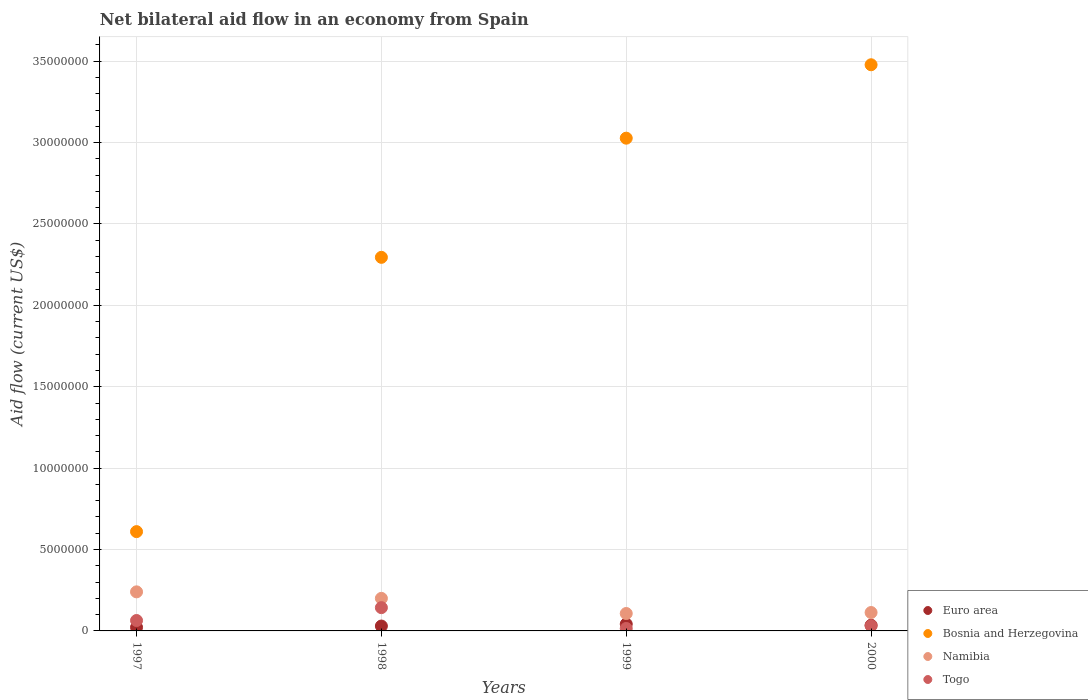How many different coloured dotlines are there?
Offer a very short reply. 4. What is the net bilateral aid flow in Euro area in 1998?
Offer a very short reply. 3.00e+05. Across all years, what is the maximum net bilateral aid flow in Namibia?
Provide a short and direct response. 2.40e+06. Across all years, what is the minimum net bilateral aid flow in Namibia?
Offer a very short reply. 1.07e+06. In which year was the net bilateral aid flow in Euro area minimum?
Your answer should be very brief. 1997. What is the total net bilateral aid flow in Namibia in the graph?
Your response must be concise. 6.60e+06. What is the difference between the net bilateral aid flow in Euro area in 1998 and the net bilateral aid flow in Namibia in 1997?
Your answer should be compact. -2.10e+06. What is the average net bilateral aid flow in Bosnia and Herzegovina per year?
Give a very brief answer. 2.35e+07. In the year 1998, what is the difference between the net bilateral aid flow in Euro area and net bilateral aid flow in Namibia?
Ensure brevity in your answer.  -1.70e+06. In how many years, is the net bilateral aid flow in Togo greater than 34000000 US$?
Provide a short and direct response. 0. What is the ratio of the net bilateral aid flow in Namibia in 1998 to that in 1999?
Offer a very short reply. 1.87. Is the net bilateral aid flow in Namibia in 1998 less than that in 1999?
Make the answer very short. No. What is the difference between the highest and the lowest net bilateral aid flow in Togo?
Make the answer very short. 1.28e+06. In how many years, is the net bilateral aid flow in Euro area greater than the average net bilateral aid flow in Euro area taken over all years?
Provide a short and direct response. 2. Is the sum of the net bilateral aid flow in Euro area in 1998 and 2000 greater than the maximum net bilateral aid flow in Togo across all years?
Offer a very short reply. No. Is it the case that in every year, the sum of the net bilateral aid flow in Bosnia and Herzegovina and net bilateral aid flow in Euro area  is greater than the sum of net bilateral aid flow in Namibia and net bilateral aid flow in Togo?
Your answer should be compact. Yes. Is it the case that in every year, the sum of the net bilateral aid flow in Togo and net bilateral aid flow in Euro area  is greater than the net bilateral aid flow in Bosnia and Herzegovina?
Offer a very short reply. No. Is the net bilateral aid flow in Euro area strictly less than the net bilateral aid flow in Bosnia and Herzegovina over the years?
Keep it short and to the point. Yes. How many dotlines are there?
Your answer should be very brief. 4. How many years are there in the graph?
Provide a succinct answer. 4. Where does the legend appear in the graph?
Your answer should be compact. Bottom right. How are the legend labels stacked?
Offer a terse response. Vertical. What is the title of the graph?
Offer a terse response. Net bilateral aid flow in an economy from Spain. Does "Cyprus" appear as one of the legend labels in the graph?
Offer a terse response. No. What is the label or title of the X-axis?
Keep it short and to the point. Years. What is the Aid flow (current US$) of Euro area in 1997?
Ensure brevity in your answer.  2.20e+05. What is the Aid flow (current US$) in Bosnia and Herzegovina in 1997?
Your answer should be very brief. 6.10e+06. What is the Aid flow (current US$) in Namibia in 1997?
Your response must be concise. 2.40e+06. What is the Aid flow (current US$) in Togo in 1997?
Make the answer very short. 6.40e+05. What is the Aid flow (current US$) of Bosnia and Herzegovina in 1998?
Give a very brief answer. 2.30e+07. What is the Aid flow (current US$) in Togo in 1998?
Make the answer very short. 1.43e+06. What is the Aid flow (current US$) of Euro area in 1999?
Offer a very short reply. 4.20e+05. What is the Aid flow (current US$) in Bosnia and Herzegovina in 1999?
Provide a succinct answer. 3.03e+07. What is the Aid flow (current US$) in Namibia in 1999?
Your response must be concise. 1.07e+06. What is the Aid flow (current US$) in Bosnia and Herzegovina in 2000?
Make the answer very short. 3.48e+07. What is the Aid flow (current US$) in Namibia in 2000?
Offer a very short reply. 1.13e+06. Across all years, what is the maximum Aid flow (current US$) in Bosnia and Herzegovina?
Offer a terse response. 3.48e+07. Across all years, what is the maximum Aid flow (current US$) in Namibia?
Your answer should be compact. 2.40e+06. Across all years, what is the maximum Aid flow (current US$) in Togo?
Offer a terse response. 1.43e+06. Across all years, what is the minimum Aid flow (current US$) of Euro area?
Offer a very short reply. 2.20e+05. Across all years, what is the minimum Aid flow (current US$) in Bosnia and Herzegovina?
Your answer should be compact. 6.10e+06. Across all years, what is the minimum Aid flow (current US$) in Namibia?
Ensure brevity in your answer.  1.07e+06. Across all years, what is the minimum Aid flow (current US$) of Togo?
Make the answer very short. 1.50e+05. What is the total Aid flow (current US$) of Euro area in the graph?
Give a very brief answer. 1.29e+06. What is the total Aid flow (current US$) of Bosnia and Herzegovina in the graph?
Ensure brevity in your answer.  9.41e+07. What is the total Aid flow (current US$) in Namibia in the graph?
Ensure brevity in your answer.  6.60e+06. What is the total Aid flow (current US$) in Togo in the graph?
Your response must be concise. 2.54e+06. What is the difference between the Aid flow (current US$) of Bosnia and Herzegovina in 1997 and that in 1998?
Your answer should be compact. -1.68e+07. What is the difference between the Aid flow (current US$) of Togo in 1997 and that in 1998?
Offer a terse response. -7.90e+05. What is the difference between the Aid flow (current US$) of Euro area in 1997 and that in 1999?
Your answer should be very brief. -2.00e+05. What is the difference between the Aid flow (current US$) of Bosnia and Herzegovina in 1997 and that in 1999?
Keep it short and to the point. -2.42e+07. What is the difference between the Aid flow (current US$) in Namibia in 1997 and that in 1999?
Offer a terse response. 1.33e+06. What is the difference between the Aid flow (current US$) in Togo in 1997 and that in 1999?
Keep it short and to the point. 4.90e+05. What is the difference between the Aid flow (current US$) in Bosnia and Herzegovina in 1997 and that in 2000?
Offer a terse response. -2.87e+07. What is the difference between the Aid flow (current US$) of Namibia in 1997 and that in 2000?
Offer a very short reply. 1.27e+06. What is the difference between the Aid flow (current US$) of Bosnia and Herzegovina in 1998 and that in 1999?
Your answer should be compact. -7.32e+06. What is the difference between the Aid flow (current US$) in Namibia in 1998 and that in 1999?
Your answer should be compact. 9.30e+05. What is the difference between the Aid flow (current US$) in Togo in 1998 and that in 1999?
Offer a terse response. 1.28e+06. What is the difference between the Aid flow (current US$) in Bosnia and Herzegovina in 1998 and that in 2000?
Offer a very short reply. -1.18e+07. What is the difference between the Aid flow (current US$) in Namibia in 1998 and that in 2000?
Offer a very short reply. 8.70e+05. What is the difference between the Aid flow (current US$) in Togo in 1998 and that in 2000?
Ensure brevity in your answer.  1.11e+06. What is the difference between the Aid flow (current US$) of Bosnia and Herzegovina in 1999 and that in 2000?
Give a very brief answer. -4.51e+06. What is the difference between the Aid flow (current US$) in Namibia in 1999 and that in 2000?
Provide a succinct answer. -6.00e+04. What is the difference between the Aid flow (current US$) in Euro area in 1997 and the Aid flow (current US$) in Bosnia and Herzegovina in 1998?
Make the answer very short. -2.27e+07. What is the difference between the Aid flow (current US$) in Euro area in 1997 and the Aid flow (current US$) in Namibia in 1998?
Give a very brief answer. -1.78e+06. What is the difference between the Aid flow (current US$) in Euro area in 1997 and the Aid flow (current US$) in Togo in 1998?
Your response must be concise. -1.21e+06. What is the difference between the Aid flow (current US$) of Bosnia and Herzegovina in 1997 and the Aid flow (current US$) of Namibia in 1998?
Offer a terse response. 4.10e+06. What is the difference between the Aid flow (current US$) in Bosnia and Herzegovina in 1997 and the Aid flow (current US$) in Togo in 1998?
Provide a short and direct response. 4.67e+06. What is the difference between the Aid flow (current US$) in Namibia in 1997 and the Aid flow (current US$) in Togo in 1998?
Your answer should be very brief. 9.70e+05. What is the difference between the Aid flow (current US$) in Euro area in 1997 and the Aid flow (current US$) in Bosnia and Herzegovina in 1999?
Offer a terse response. -3.00e+07. What is the difference between the Aid flow (current US$) in Euro area in 1997 and the Aid flow (current US$) in Namibia in 1999?
Your response must be concise. -8.50e+05. What is the difference between the Aid flow (current US$) in Bosnia and Herzegovina in 1997 and the Aid flow (current US$) in Namibia in 1999?
Make the answer very short. 5.03e+06. What is the difference between the Aid flow (current US$) in Bosnia and Herzegovina in 1997 and the Aid flow (current US$) in Togo in 1999?
Provide a short and direct response. 5.95e+06. What is the difference between the Aid flow (current US$) of Namibia in 1997 and the Aid flow (current US$) of Togo in 1999?
Ensure brevity in your answer.  2.25e+06. What is the difference between the Aid flow (current US$) in Euro area in 1997 and the Aid flow (current US$) in Bosnia and Herzegovina in 2000?
Offer a terse response. -3.46e+07. What is the difference between the Aid flow (current US$) in Euro area in 1997 and the Aid flow (current US$) in Namibia in 2000?
Your answer should be very brief. -9.10e+05. What is the difference between the Aid flow (current US$) in Bosnia and Herzegovina in 1997 and the Aid flow (current US$) in Namibia in 2000?
Give a very brief answer. 4.97e+06. What is the difference between the Aid flow (current US$) of Bosnia and Herzegovina in 1997 and the Aid flow (current US$) of Togo in 2000?
Keep it short and to the point. 5.78e+06. What is the difference between the Aid flow (current US$) in Namibia in 1997 and the Aid flow (current US$) in Togo in 2000?
Give a very brief answer. 2.08e+06. What is the difference between the Aid flow (current US$) of Euro area in 1998 and the Aid flow (current US$) of Bosnia and Herzegovina in 1999?
Your answer should be very brief. -3.00e+07. What is the difference between the Aid flow (current US$) of Euro area in 1998 and the Aid flow (current US$) of Namibia in 1999?
Give a very brief answer. -7.70e+05. What is the difference between the Aid flow (current US$) of Euro area in 1998 and the Aid flow (current US$) of Togo in 1999?
Offer a terse response. 1.50e+05. What is the difference between the Aid flow (current US$) of Bosnia and Herzegovina in 1998 and the Aid flow (current US$) of Namibia in 1999?
Make the answer very short. 2.19e+07. What is the difference between the Aid flow (current US$) of Bosnia and Herzegovina in 1998 and the Aid flow (current US$) of Togo in 1999?
Keep it short and to the point. 2.28e+07. What is the difference between the Aid flow (current US$) in Namibia in 1998 and the Aid flow (current US$) in Togo in 1999?
Your answer should be compact. 1.85e+06. What is the difference between the Aid flow (current US$) of Euro area in 1998 and the Aid flow (current US$) of Bosnia and Herzegovina in 2000?
Make the answer very short. -3.45e+07. What is the difference between the Aid flow (current US$) of Euro area in 1998 and the Aid flow (current US$) of Namibia in 2000?
Give a very brief answer. -8.30e+05. What is the difference between the Aid flow (current US$) of Euro area in 1998 and the Aid flow (current US$) of Togo in 2000?
Offer a very short reply. -2.00e+04. What is the difference between the Aid flow (current US$) of Bosnia and Herzegovina in 1998 and the Aid flow (current US$) of Namibia in 2000?
Make the answer very short. 2.18e+07. What is the difference between the Aid flow (current US$) of Bosnia and Herzegovina in 1998 and the Aid flow (current US$) of Togo in 2000?
Offer a very short reply. 2.26e+07. What is the difference between the Aid flow (current US$) of Namibia in 1998 and the Aid flow (current US$) of Togo in 2000?
Make the answer very short. 1.68e+06. What is the difference between the Aid flow (current US$) in Euro area in 1999 and the Aid flow (current US$) in Bosnia and Herzegovina in 2000?
Your answer should be compact. -3.44e+07. What is the difference between the Aid flow (current US$) of Euro area in 1999 and the Aid flow (current US$) of Namibia in 2000?
Provide a succinct answer. -7.10e+05. What is the difference between the Aid flow (current US$) of Bosnia and Herzegovina in 1999 and the Aid flow (current US$) of Namibia in 2000?
Ensure brevity in your answer.  2.91e+07. What is the difference between the Aid flow (current US$) in Bosnia and Herzegovina in 1999 and the Aid flow (current US$) in Togo in 2000?
Your response must be concise. 3.00e+07. What is the difference between the Aid flow (current US$) of Namibia in 1999 and the Aid flow (current US$) of Togo in 2000?
Your answer should be compact. 7.50e+05. What is the average Aid flow (current US$) in Euro area per year?
Offer a very short reply. 3.22e+05. What is the average Aid flow (current US$) in Bosnia and Herzegovina per year?
Your response must be concise. 2.35e+07. What is the average Aid flow (current US$) of Namibia per year?
Provide a short and direct response. 1.65e+06. What is the average Aid flow (current US$) of Togo per year?
Provide a succinct answer. 6.35e+05. In the year 1997, what is the difference between the Aid flow (current US$) in Euro area and Aid flow (current US$) in Bosnia and Herzegovina?
Offer a very short reply. -5.88e+06. In the year 1997, what is the difference between the Aid flow (current US$) in Euro area and Aid flow (current US$) in Namibia?
Provide a succinct answer. -2.18e+06. In the year 1997, what is the difference between the Aid flow (current US$) of Euro area and Aid flow (current US$) of Togo?
Provide a succinct answer. -4.20e+05. In the year 1997, what is the difference between the Aid flow (current US$) in Bosnia and Herzegovina and Aid flow (current US$) in Namibia?
Keep it short and to the point. 3.70e+06. In the year 1997, what is the difference between the Aid flow (current US$) in Bosnia and Herzegovina and Aid flow (current US$) in Togo?
Ensure brevity in your answer.  5.46e+06. In the year 1997, what is the difference between the Aid flow (current US$) in Namibia and Aid flow (current US$) in Togo?
Ensure brevity in your answer.  1.76e+06. In the year 1998, what is the difference between the Aid flow (current US$) in Euro area and Aid flow (current US$) in Bosnia and Herzegovina?
Make the answer very short. -2.26e+07. In the year 1998, what is the difference between the Aid flow (current US$) of Euro area and Aid flow (current US$) of Namibia?
Ensure brevity in your answer.  -1.70e+06. In the year 1998, what is the difference between the Aid flow (current US$) of Euro area and Aid flow (current US$) of Togo?
Give a very brief answer. -1.13e+06. In the year 1998, what is the difference between the Aid flow (current US$) in Bosnia and Herzegovina and Aid flow (current US$) in Namibia?
Give a very brief answer. 2.10e+07. In the year 1998, what is the difference between the Aid flow (current US$) in Bosnia and Herzegovina and Aid flow (current US$) in Togo?
Keep it short and to the point. 2.15e+07. In the year 1998, what is the difference between the Aid flow (current US$) in Namibia and Aid flow (current US$) in Togo?
Make the answer very short. 5.70e+05. In the year 1999, what is the difference between the Aid flow (current US$) in Euro area and Aid flow (current US$) in Bosnia and Herzegovina?
Make the answer very short. -2.98e+07. In the year 1999, what is the difference between the Aid flow (current US$) of Euro area and Aid flow (current US$) of Namibia?
Provide a short and direct response. -6.50e+05. In the year 1999, what is the difference between the Aid flow (current US$) in Bosnia and Herzegovina and Aid flow (current US$) in Namibia?
Your answer should be compact. 2.92e+07. In the year 1999, what is the difference between the Aid flow (current US$) of Bosnia and Herzegovina and Aid flow (current US$) of Togo?
Your response must be concise. 3.01e+07. In the year 1999, what is the difference between the Aid flow (current US$) in Namibia and Aid flow (current US$) in Togo?
Make the answer very short. 9.20e+05. In the year 2000, what is the difference between the Aid flow (current US$) of Euro area and Aid flow (current US$) of Bosnia and Herzegovina?
Keep it short and to the point. -3.44e+07. In the year 2000, what is the difference between the Aid flow (current US$) of Euro area and Aid flow (current US$) of Namibia?
Provide a succinct answer. -7.80e+05. In the year 2000, what is the difference between the Aid flow (current US$) of Bosnia and Herzegovina and Aid flow (current US$) of Namibia?
Give a very brief answer. 3.36e+07. In the year 2000, what is the difference between the Aid flow (current US$) of Bosnia and Herzegovina and Aid flow (current US$) of Togo?
Keep it short and to the point. 3.45e+07. In the year 2000, what is the difference between the Aid flow (current US$) in Namibia and Aid flow (current US$) in Togo?
Offer a terse response. 8.10e+05. What is the ratio of the Aid flow (current US$) in Euro area in 1997 to that in 1998?
Offer a very short reply. 0.73. What is the ratio of the Aid flow (current US$) in Bosnia and Herzegovina in 1997 to that in 1998?
Make the answer very short. 0.27. What is the ratio of the Aid flow (current US$) in Namibia in 1997 to that in 1998?
Ensure brevity in your answer.  1.2. What is the ratio of the Aid flow (current US$) of Togo in 1997 to that in 1998?
Give a very brief answer. 0.45. What is the ratio of the Aid flow (current US$) in Euro area in 1997 to that in 1999?
Your answer should be very brief. 0.52. What is the ratio of the Aid flow (current US$) of Bosnia and Herzegovina in 1997 to that in 1999?
Provide a short and direct response. 0.2. What is the ratio of the Aid flow (current US$) in Namibia in 1997 to that in 1999?
Your response must be concise. 2.24. What is the ratio of the Aid flow (current US$) in Togo in 1997 to that in 1999?
Give a very brief answer. 4.27. What is the ratio of the Aid flow (current US$) in Euro area in 1997 to that in 2000?
Provide a short and direct response. 0.63. What is the ratio of the Aid flow (current US$) of Bosnia and Herzegovina in 1997 to that in 2000?
Offer a very short reply. 0.18. What is the ratio of the Aid flow (current US$) in Namibia in 1997 to that in 2000?
Your answer should be very brief. 2.12. What is the ratio of the Aid flow (current US$) of Togo in 1997 to that in 2000?
Your answer should be compact. 2. What is the ratio of the Aid flow (current US$) in Bosnia and Herzegovina in 1998 to that in 1999?
Your answer should be compact. 0.76. What is the ratio of the Aid flow (current US$) in Namibia in 1998 to that in 1999?
Provide a short and direct response. 1.87. What is the ratio of the Aid flow (current US$) in Togo in 1998 to that in 1999?
Provide a short and direct response. 9.53. What is the ratio of the Aid flow (current US$) in Bosnia and Herzegovina in 1998 to that in 2000?
Keep it short and to the point. 0.66. What is the ratio of the Aid flow (current US$) of Namibia in 1998 to that in 2000?
Keep it short and to the point. 1.77. What is the ratio of the Aid flow (current US$) in Togo in 1998 to that in 2000?
Provide a succinct answer. 4.47. What is the ratio of the Aid flow (current US$) of Bosnia and Herzegovina in 1999 to that in 2000?
Ensure brevity in your answer.  0.87. What is the ratio of the Aid flow (current US$) in Namibia in 1999 to that in 2000?
Your response must be concise. 0.95. What is the ratio of the Aid flow (current US$) in Togo in 1999 to that in 2000?
Provide a succinct answer. 0.47. What is the difference between the highest and the second highest Aid flow (current US$) of Bosnia and Herzegovina?
Give a very brief answer. 4.51e+06. What is the difference between the highest and the second highest Aid flow (current US$) in Togo?
Keep it short and to the point. 7.90e+05. What is the difference between the highest and the lowest Aid flow (current US$) in Bosnia and Herzegovina?
Keep it short and to the point. 2.87e+07. What is the difference between the highest and the lowest Aid flow (current US$) of Namibia?
Give a very brief answer. 1.33e+06. What is the difference between the highest and the lowest Aid flow (current US$) in Togo?
Offer a very short reply. 1.28e+06. 